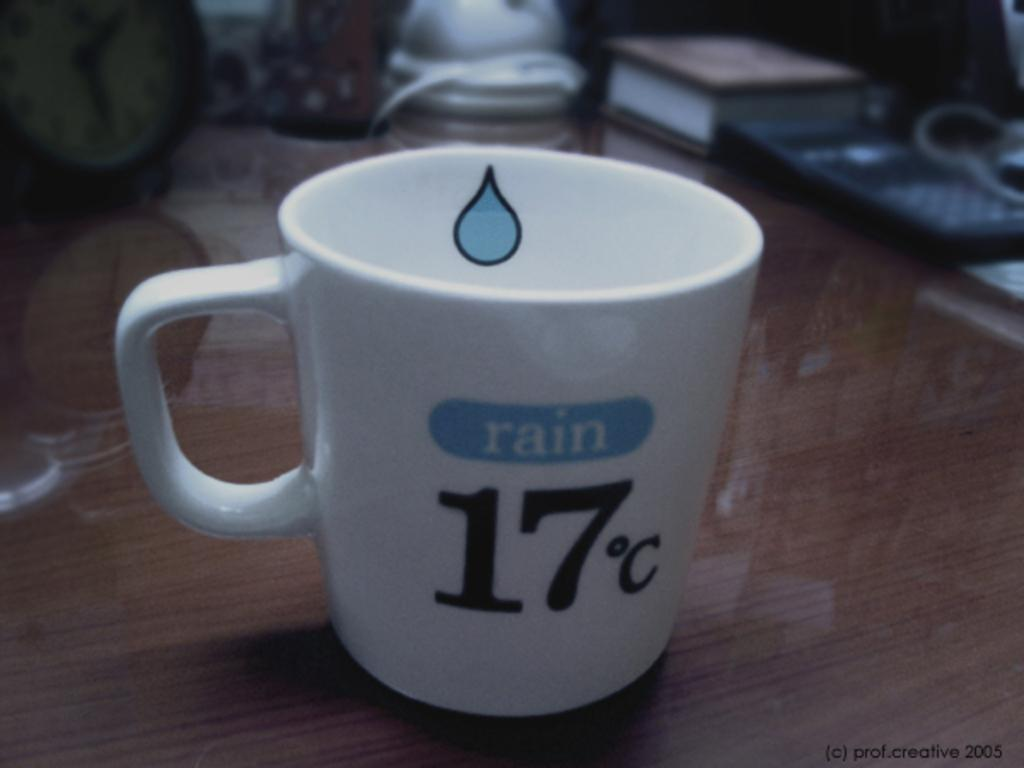<image>
Relay a brief, clear account of the picture shown. a mug that has 17 degrees celsius on it 